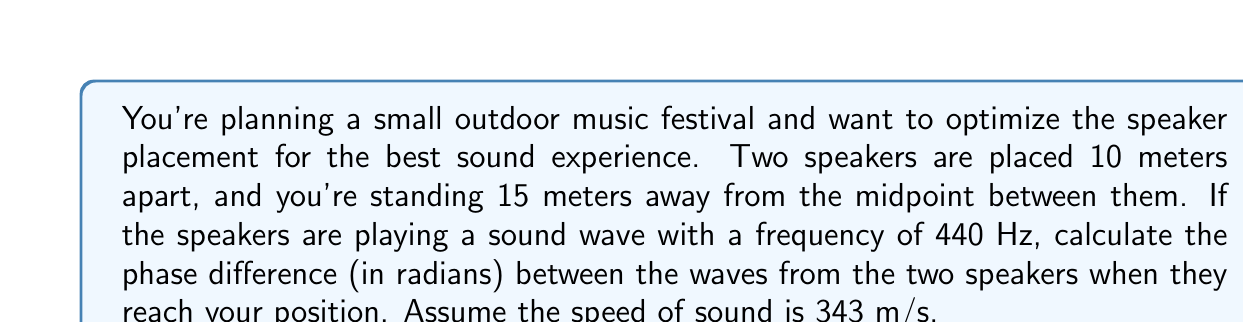Provide a solution to this math problem. Let's approach this step-by-step:

1. First, we need to calculate the wavelength of the sound:
   $$\lambda = \frac{v}{f} = \frac{343 \text{ m/s}}{440 \text{ Hz}} = 0.78 \text{ m}$$

2. Next, we need to find the distance from each speaker to your position. We can use the Pythagorean theorem:
   $$d = \sqrt{7.5^2 + 15^2} = \sqrt{56.25 + 225} = \sqrt{281.25} = 16.77 \text{ m}$$

3. The path difference between the two waves is:
   $$\Delta d = 2d - 20 = 2(16.77) - 20 = 13.54 \text{ m}$$

4. To convert this path difference to a phase difference, we use:
   $$\Delta \phi = \frac{2\pi}{\lambda} \Delta d$$

5. Substituting our values:
   $$\Delta \phi = \frac{2\pi}{0.78} \cdot 13.54 = 109.15 \text{ radians}$$

6. We can express this in terms of $2\pi$:
   $$\Delta \phi = 17.37 \cdot 2\pi \text{ radians}$$

7. The fractional part is what matters for the phase difference:
   $$\Delta \phi = 0.37 \cdot 2\pi = 2.32 \text{ radians}$$
Answer: 2.32 radians 